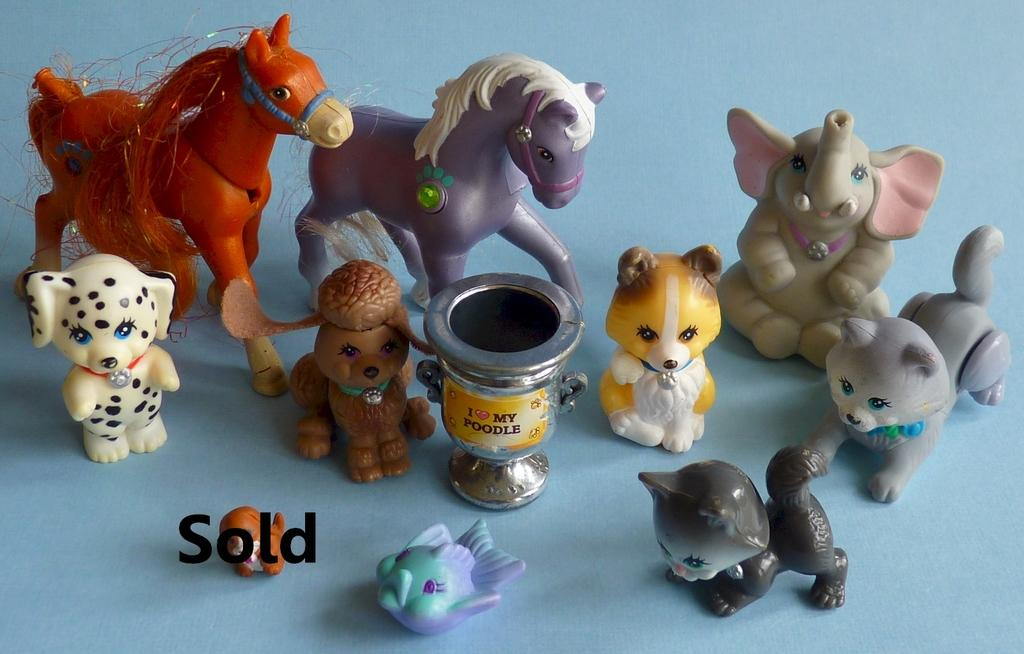What objects can be seen in the image? There are toys in the image. What else is present in the image besides toys? There is text in the image. What color is the background of the image? The background of the image is blue in color. How does the tongue help the toys in the image? There is no tongue present in the image, so it cannot help the toys. 